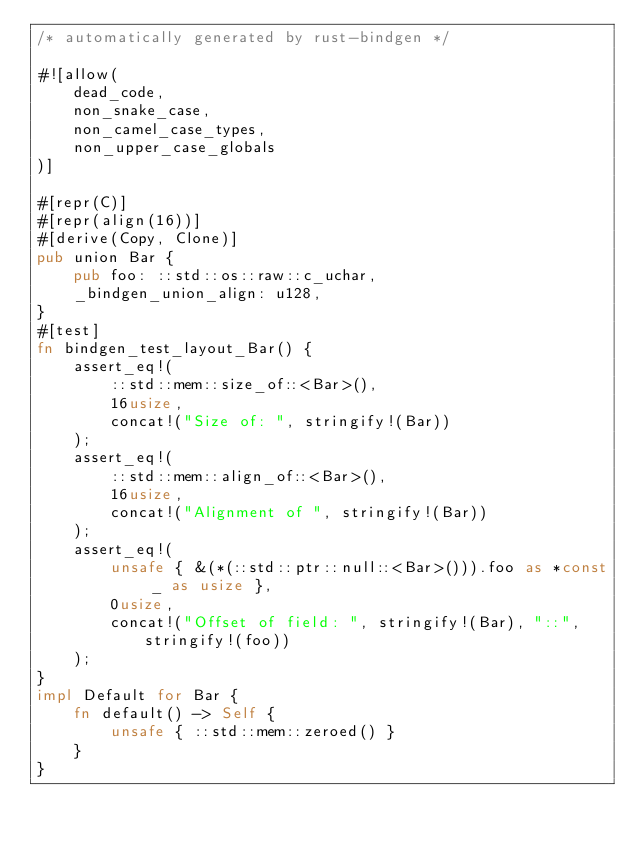Convert code to text. <code><loc_0><loc_0><loc_500><loc_500><_Rust_>/* automatically generated by rust-bindgen */

#![allow(
    dead_code,
    non_snake_case,
    non_camel_case_types,
    non_upper_case_globals
)]

#[repr(C)]
#[repr(align(16))]
#[derive(Copy, Clone)]
pub union Bar {
    pub foo: ::std::os::raw::c_uchar,
    _bindgen_union_align: u128,
}
#[test]
fn bindgen_test_layout_Bar() {
    assert_eq!(
        ::std::mem::size_of::<Bar>(),
        16usize,
        concat!("Size of: ", stringify!(Bar))
    );
    assert_eq!(
        ::std::mem::align_of::<Bar>(),
        16usize,
        concat!("Alignment of ", stringify!(Bar))
    );
    assert_eq!(
        unsafe { &(*(::std::ptr::null::<Bar>())).foo as *const _ as usize },
        0usize,
        concat!("Offset of field: ", stringify!(Bar), "::", stringify!(foo))
    );
}
impl Default for Bar {
    fn default() -> Self {
        unsafe { ::std::mem::zeroed() }
    }
}
</code> 